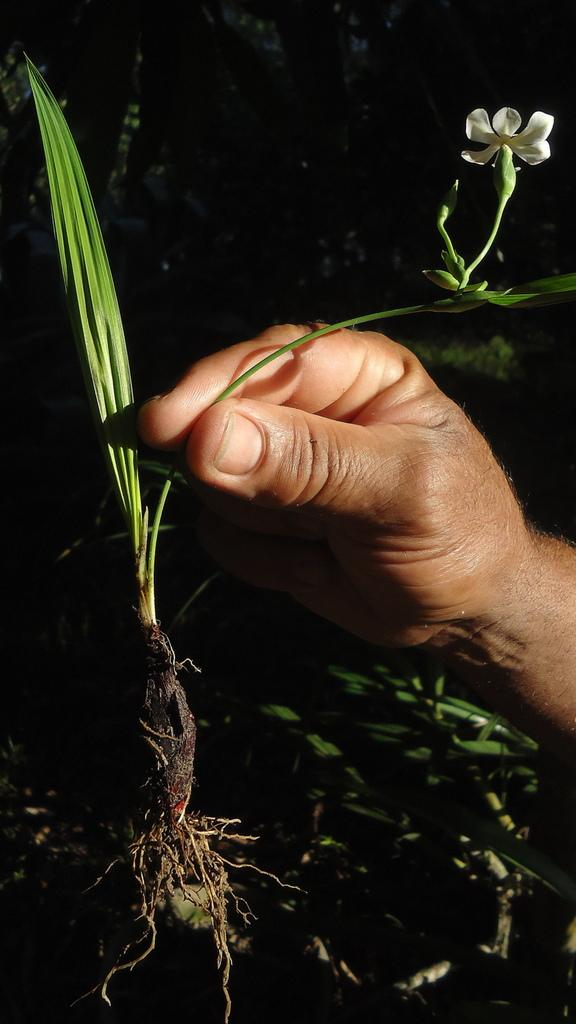What is the person's hand holding in the image? There is a person's hand holding a plant in the image. What can be seen beneath the plant in the image? The ground is visible in the image. What is present on the ground in the image? There are leaves on the ground. How would you describe the lighting in the image? The background of the image is dark. How many goldfish are swimming in the oven in the image? There are no goldfish or ovens present in the image. 